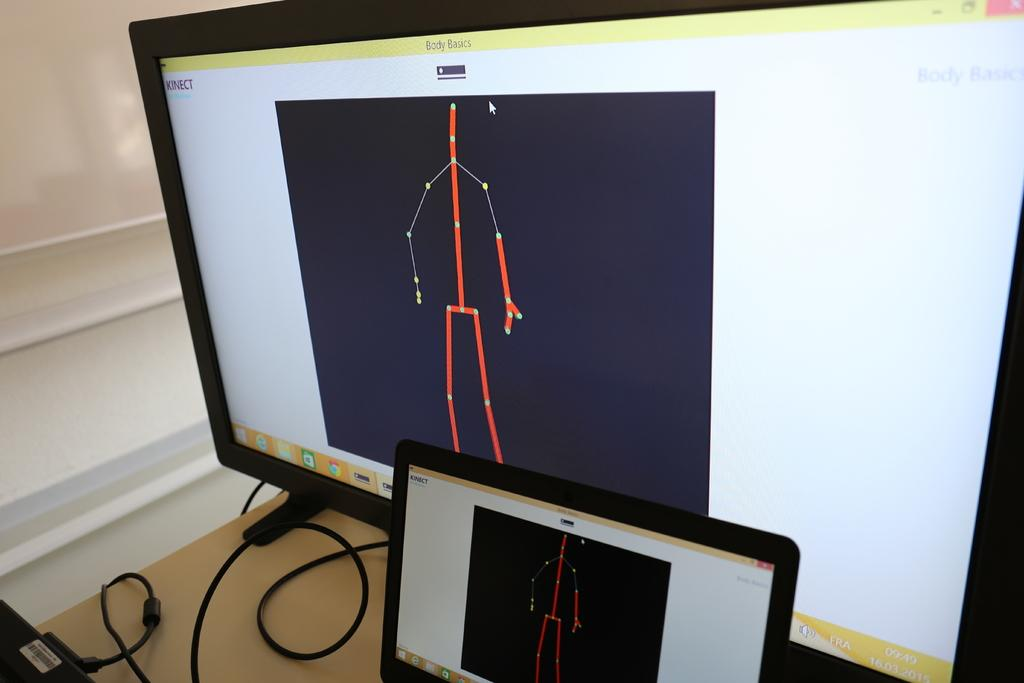<image>
Write a terse but informative summary of the picture. Body Basics is displayed on the two monitors on the table. 